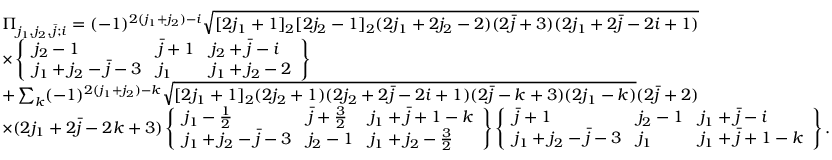<formula> <loc_0><loc_0><loc_500><loc_500>\begin{array} { r l } & { \Pi _ { j _ { 1 } , j _ { 2 } , \bar { j } ; i } = ( - 1 ) ^ { 2 ( j _ { 1 } + j _ { 2 } ) - i } \sqrt { [ 2 j _ { 1 } + 1 ] _ { 2 } [ 2 j _ { 2 } - 1 ] _ { 2 } ( 2 j _ { 1 } + 2 j _ { 2 } - 2 ) ( 2 \bar { j } + 3 ) ( 2 j _ { 1 } + 2 \bar { j } - 2 i + 1 ) } } \\ & { \times \left \{ \begin{array} { l l l } { j _ { 2 } - 1 } & { \bar { j } + 1 } & { j _ { 2 } + \bar { j } - i } \\ { j _ { 1 } + j _ { 2 } - \bar { j } - 3 } & { j _ { 1 } } & { j _ { 1 } + j _ { 2 } - 2 } \end{array} \right \} } \\ & { + \sum _ { k } ( - 1 ) ^ { 2 ( j _ { 1 } + j _ { 2 } ) - k } \sqrt { [ 2 j _ { 1 } + 1 ] _ { 2 } ( 2 j _ { 2 } + 1 ) ( 2 j _ { 2 } + 2 \bar { j } - 2 i + 1 ) ( 2 \bar { j } - k + 3 ) ( 2 j _ { 1 } - k ) } ( 2 \bar { j } + 2 ) } \\ & { \times ( 2 j _ { 1 } + 2 \bar { j } - 2 k + 3 ) \left \{ \begin{array} { l l l } { j _ { 1 } - \frac { 1 } { 2 } } & { \bar { j } + \frac { 3 } { 2 } } & { j _ { 1 } + \bar { j } + 1 - k } \\ { j _ { 1 } + j _ { 2 } - \bar { j } - 3 } & { j _ { 2 } - 1 } & { j _ { 1 } + j _ { 2 } - \frac { 3 } { 2 } } \end{array} \right \} \left \{ \begin{array} { l l l } { \bar { j } + 1 } & { j _ { 2 } - 1 } & { j _ { 1 } + \bar { j } - i } \\ { j _ { 1 } + j _ { 2 } - \bar { j } - 3 } & { j _ { 1 } } & { j _ { 1 } + \bar { j } + 1 - k } \end{array} \right \} . } \end{array}</formula> 